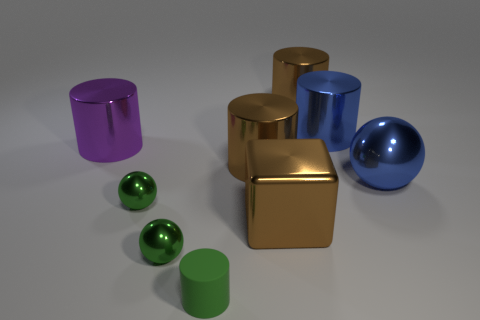How many small shiny things are there?
Your answer should be very brief. 2. What shape is the blue object that is behind the large object left of the tiny cylinder?
Make the answer very short. Cylinder. There is a small matte cylinder; how many blue balls are left of it?
Offer a very short reply. 0. Are the cube and the large blue object to the left of the blue sphere made of the same material?
Keep it short and to the point. Yes. Is there a brown object of the same size as the blue sphere?
Your response must be concise. Yes. Are there the same number of large purple objects that are right of the large blue metal ball and purple things?
Keep it short and to the point. No. What size is the green cylinder?
Your answer should be compact. Small. There is a green metal thing that is in front of the cube; what number of brown cylinders are right of it?
Ensure brevity in your answer.  2. What is the shape of the metallic thing that is behind the large shiny ball and on the left side of the tiny green matte cylinder?
Make the answer very short. Cylinder. How many tiny shiny spheres have the same color as the small rubber thing?
Provide a short and direct response. 2. 